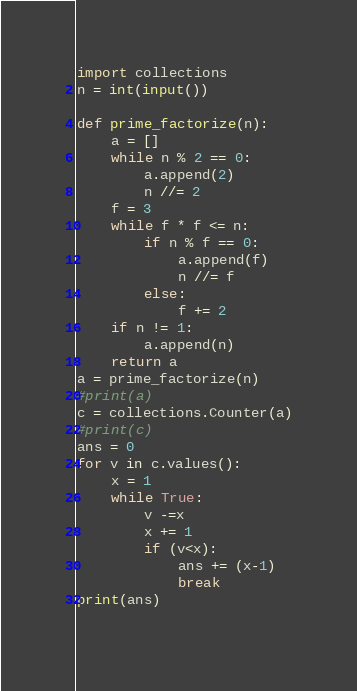<code> <loc_0><loc_0><loc_500><loc_500><_Python_>import collections
n = int(input())

def prime_factorize(n):
    a = []
    while n % 2 == 0:
        a.append(2)
        n //= 2
    f = 3
    while f * f <= n:
        if n % f == 0:
            a.append(f)
            n //= f
        else:
            f += 2
    if n != 1:
        a.append(n)
    return a
a = prime_factorize(n)
#print(a)
c = collections.Counter(a)
#print(c)
ans = 0
for v in c.values():
    x = 1
    while True:
        v -=x
        x += 1
        if (v<x):
            ans += (x-1)
            break
print(ans)
            </code> 